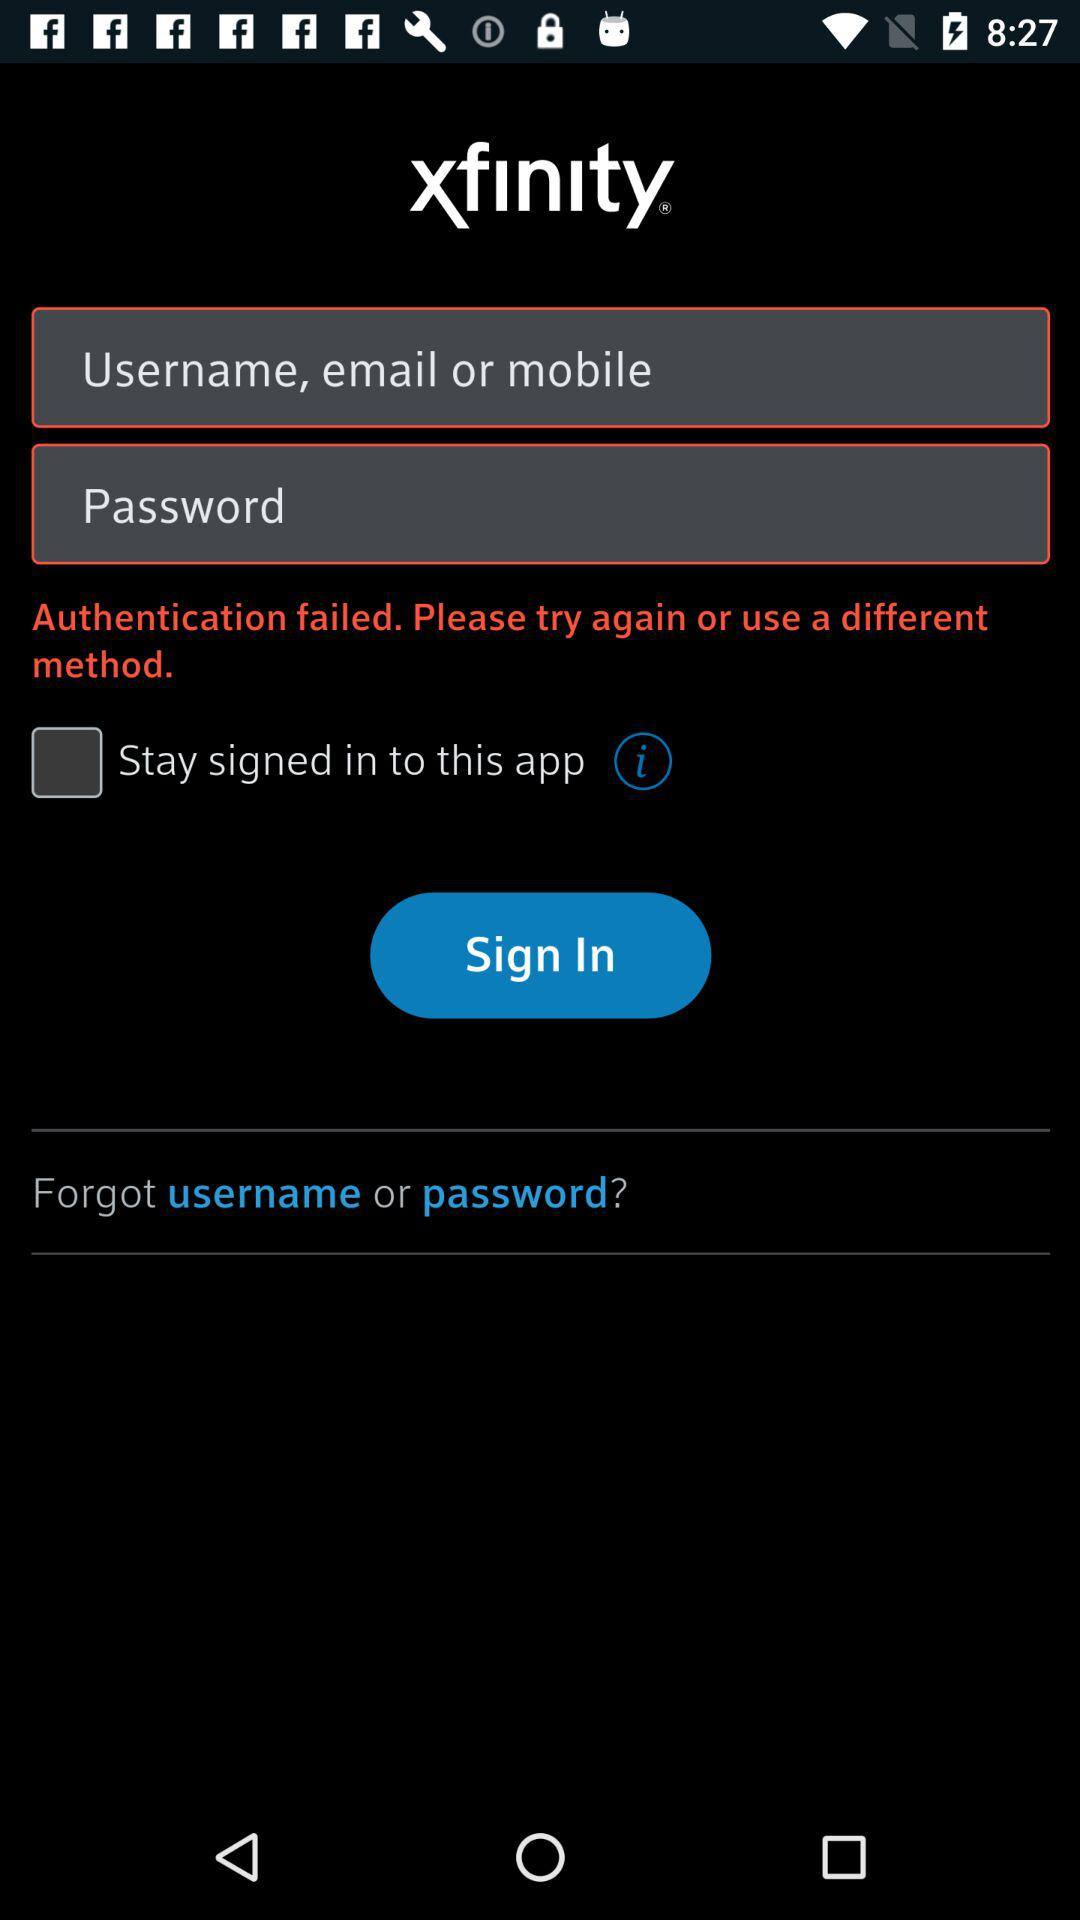What is the status of the "Stay signed in to this app"? The status of the "Stay signed in to this app" is "off". 